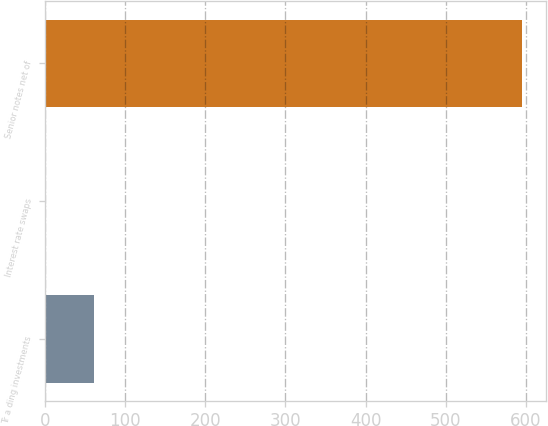Convert chart to OTSL. <chart><loc_0><loc_0><loc_500><loc_500><bar_chart><fcel>Tr a ding investments<fcel>Interest rate swaps<fcel>Senior notes net of<nl><fcel>60.82<fcel>1.4<fcel>595.6<nl></chart> 